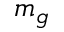Convert formula to latex. <formula><loc_0><loc_0><loc_500><loc_500>m _ { g }</formula> 